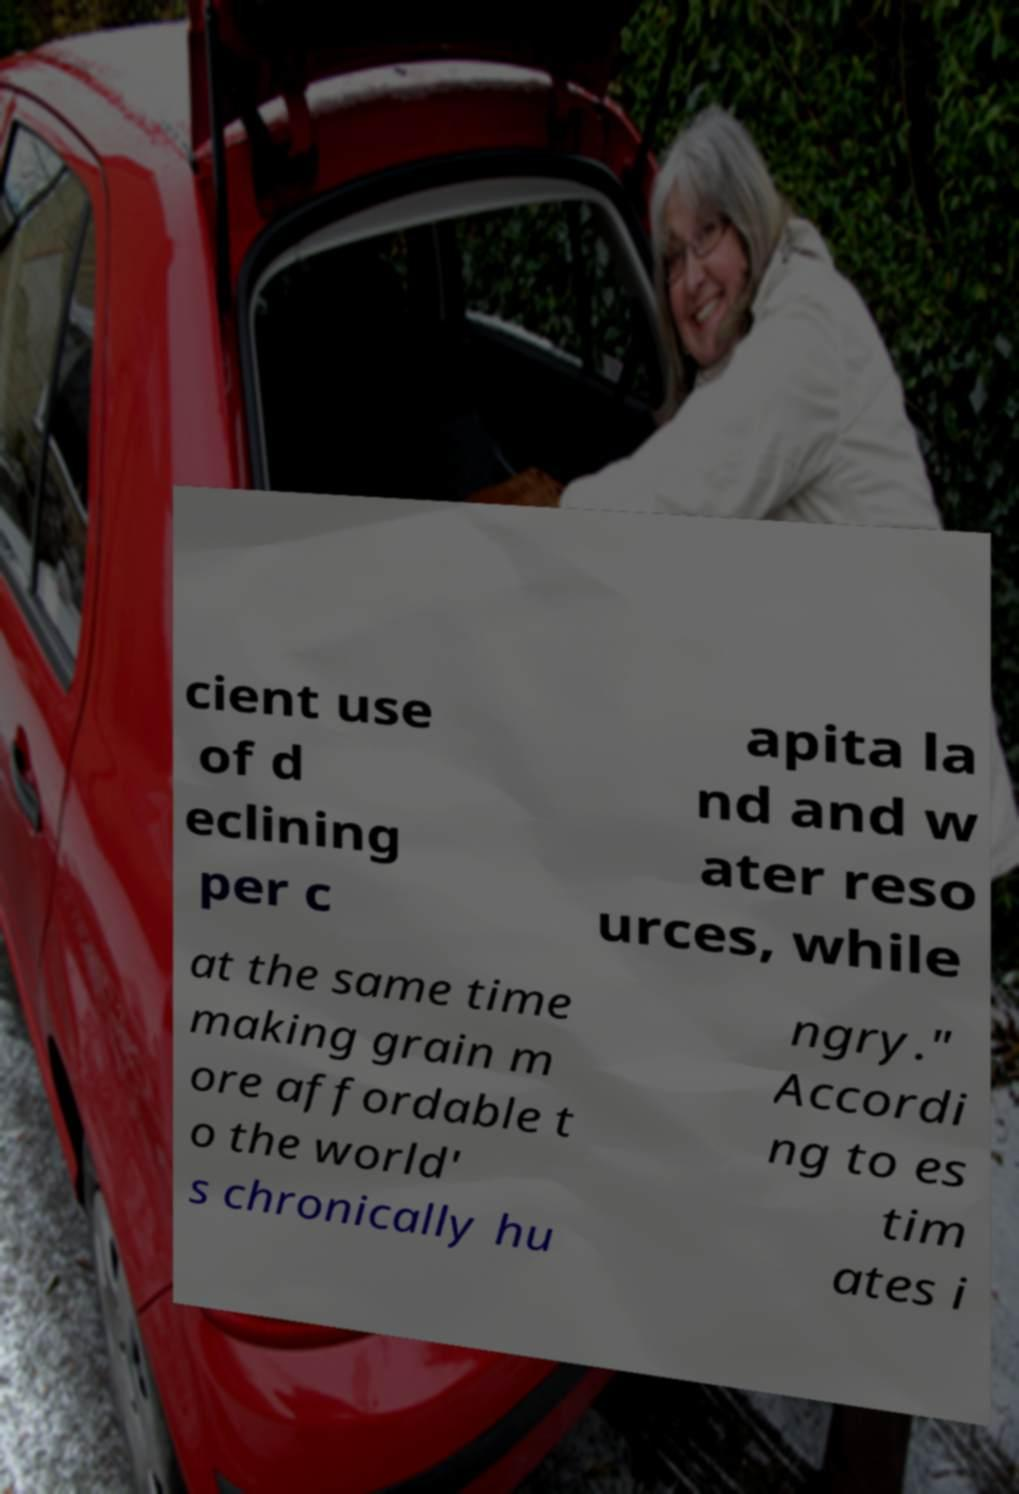Could you assist in decoding the text presented in this image and type it out clearly? cient use of d eclining per c apita la nd and w ater reso urces, while at the same time making grain m ore affordable t o the world' s chronically hu ngry." Accordi ng to es tim ates i 